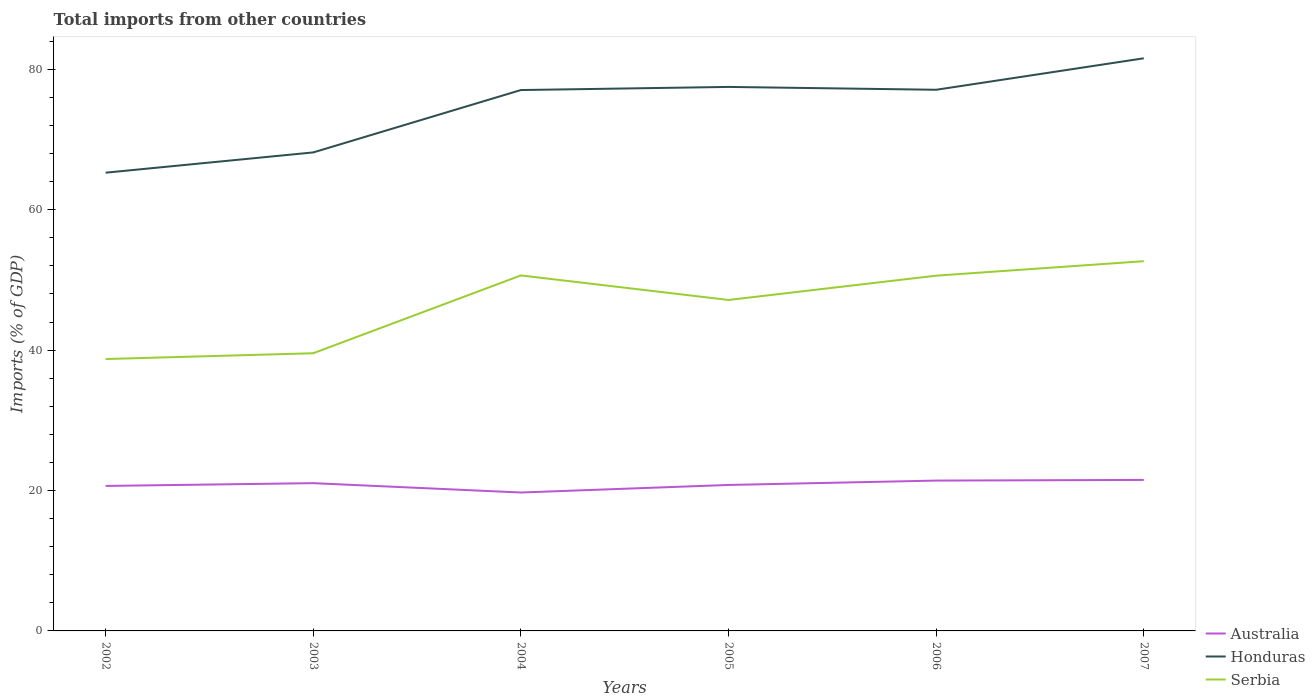How many different coloured lines are there?
Keep it short and to the point. 3. Does the line corresponding to Serbia intersect with the line corresponding to Honduras?
Your answer should be compact. No. Is the number of lines equal to the number of legend labels?
Make the answer very short. Yes. Across all years, what is the maximum total imports in Serbia?
Your response must be concise. 38.73. What is the total total imports in Serbia in the graph?
Provide a short and direct response. 0.03. What is the difference between the highest and the second highest total imports in Serbia?
Provide a short and direct response. 13.94. How many lines are there?
Provide a short and direct response. 3. How many years are there in the graph?
Offer a very short reply. 6. Are the values on the major ticks of Y-axis written in scientific E-notation?
Provide a short and direct response. No. Does the graph contain any zero values?
Keep it short and to the point. No. Does the graph contain grids?
Offer a terse response. No. What is the title of the graph?
Ensure brevity in your answer.  Total imports from other countries. What is the label or title of the X-axis?
Your answer should be very brief. Years. What is the label or title of the Y-axis?
Offer a very short reply. Imports (% of GDP). What is the Imports (% of GDP) of Australia in 2002?
Provide a short and direct response. 20.65. What is the Imports (% of GDP) in Honduras in 2002?
Your answer should be very brief. 65.27. What is the Imports (% of GDP) in Serbia in 2002?
Ensure brevity in your answer.  38.73. What is the Imports (% of GDP) of Australia in 2003?
Provide a short and direct response. 21.05. What is the Imports (% of GDP) of Honduras in 2003?
Provide a short and direct response. 68.15. What is the Imports (% of GDP) in Serbia in 2003?
Provide a short and direct response. 39.55. What is the Imports (% of GDP) of Australia in 2004?
Your response must be concise. 19.71. What is the Imports (% of GDP) of Honduras in 2004?
Make the answer very short. 77.04. What is the Imports (% of GDP) of Serbia in 2004?
Your answer should be very brief. 50.63. What is the Imports (% of GDP) of Australia in 2005?
Give a very brief answer. 20.79. What is the Imports (% of GDP) of Honduras in 2005?
Offer a terse response. 77.48. What is the Imports (% of GDP) of Serbia in 2005?
Give a very brief answer. 47.14. What is the Imports (% of GDP) of Australia in 2006?
Offer a terse response. 21.41. What is the Imports (% of GDP) in Honduras in 2006?
Your answer should be compact. 77.08. What is the Imports (% of GDP) in Serbia in 2006?
Offer a terse response. 50.6. What is the Imports (% of GDP) in Australia in 2007?
Provide a short and direct response. 21.51. What is the Imports (% of GDP) in Honduras in 2007?
Your answer should be very brief. 81.56. What is the Imports (% of GDP) in Serbia in 2007?
Keep it short and to the point. 52.66. Across all years, what is the maximum Imports (% of GDP) in Australia?
Keep it short and to the point. 21.51. Across all years, what is the maximum Imports (% of GDP) of Honduras?
Provide a succinct answer. 81.56. Across all years, what is the maximum Imports (% of GDP) in Serbia?
Your answer should be very brief. 52.66. Across all years, what is the minimum Imports (% of GDP) of Australia?
Your answer should be compact. 19.71. Across all years, what is the minimum Imports (% of GDP) in Honduras?
Make the answer very short. 65.27. Across all years, what is the minimum Imports (% of GDP) of Serbia?
Provide a short and direct response. 38.73. What is the total Imports (% of GDP) of Australia in the graph?
Make the answer very short. 125.12. What is the total Imports (% of GDP) of Honduras in the graph?
Give a very brief answer. 446.58. What is the total Imports (% of GDP) of Serbia in the graph?
Provide a short and direct response. 279.31. What is the difference between the Imports (% of GDP) of Australia in 2002 and that in 2003?
Your answer should be compact. -0.39. What is the difference between the Imports (% of GDP) of Honduras in 2002 and that in 2003?
Your response must be concise. -2.89. What is the difference between the Imports (% of GDP) of Serbia in 2002 and that in 2003?
Offer a very short reply. -0.83. What is the difference between the Imports (% of GDP) of Australia in 2002 and that in 2004?
Keep it short and to the point. 0.94. What is the difference between the Imports (% of GDP) in Honduras in 2002 and that in 2004?
Offer a terse response. -11.77. What is the difference between the Imports (% of GDP) in Serbia in 2002 and that in 2004?
Keep it short and to the point. -11.91. What is the difference between the Imports (% of GDP) of Australia in 2002 and that in 2005?
Your answer should be very brief. -0.14. What is the difference between the Imports (% of GDP) in Honduras in 2002 and that in 2005?
Provide a short and direct response. -12.22. What is the difference between the Imports (% of GDP) of Serbia in 2002 and that in 2005?
Offer a very short reply. -8.41. What is the difference between the Imports (% of GDP) of Australia in 2002 and that in 2006?
Your response must be concise. -0.76. What is the difference between the Imports (% of GDP) of Honduras in 2002 and that in 2006?
Offer a terse response. -11.81. What is the difference between the Imports (% of GDP) in Serbia in 2002 and that in 2006?
Your response must be concise. -11.87. What is the difference between the Imports (% of GDP) in Australia in 2002 and that in 2007?
Offer a very short reply. -0.85. What is the difference between the Imports (% of GDP) of Honduras in 2002 and that in 2007?
Ensure brevity in your answer.  -16.29. What is the difference between the Imports (% of GDP) in Serbia in 2002 and that in 2007?
Offer a very short reply. -13.94. What is the difference between the Imports (% of GDP) in Australia in 2003 and that in 2004?
Your answer should be compact. 1.33. What is the difference between the Imports (% of GDP) in Honduras in 2003 and that in 2004?
Provide a succinct answer. -8.88. What is the difference between the Imports (% of GDP) in Serbia in 2003 and that in 2004?
Offer a terse response. -11.08. What is the difference between the Imports (% of GDP) of Australia in 2003 and that in 2005?
Keep it short and to the point. 0.26. What is the difference between the Imports (% of GDP) in Honduras in 2003 and that in 2005?
Keep it short and to the point. -9.33. What is the difference between the Imports (% of GDP) in Serbia in 2003 and that in 2005?
Ensure brevity in your answer.  -7.59. What is the difference between the Imports (% of GDP) of Australia in 2003 and that in 2006?
Offer a very short reply. -0.37. What is the difference between the Imports (% of GDP) in Honduras in 2003 and that in 2006?
Give a very brief answer. -8.92. What is the difference between the Imports (% of GDP) in Serbia in 2003 and that in 2006?
Your answer should be very brief. -11.05. What is the difference between the Imports (% of GDP) of Australia in 2003 and that in 2007?
Give a very brief answer. -0.46. What is the difference between the Imports (% of GDP) in Honduras in 2003 and that in 2007?
Provide a succinct answer. -13.41. What is the difference between the Imports (% of GDP) in Serbia in 2003 and that in 2007?
Make the answer very short. -13.11. What is the difference between the Imports (% of GDP) of Australia in 2004 and that in 2005?
Offer a very short reply. -1.08. What is the difference between the Imports (% of GDP) of Honduras in 2004 and that in 2005?
Offer a very short reply. -0.45. What is the difference between the Imports (% of GDP) of Serbia in 2004 and that in 2005?
Your response must be concise. 3.49. What is the difference between the Imports (% of GDP) in Australia in 2004 and that in 2006?
Provide a succinct answer. -1.7. What is the difference between the Imports (% of GDP) in Honduras in 2004 and that in 2006?
Keep it short and to the point. -0.04. What is the difference between the Imports (% of GDP) of Serbia in 2004 and that in 2006?
Keep it short and to the point. 0.03. What is the difference between the Imports (% of GDP) of Australia in 2004 and that in 2007?
Provide a short and direct response. -1.79. What is the difference between the Imports (% of GDP) in Honduras in 2004 and that in 2007?
Provide a short and direct response. -4.52. What is the difference between the Imports (% of GDP) of Serbia in 2004 and that in 2007?
Provide a short and direct response. -2.03. What is the difference between the Imports (% of GDP) of Australia in 2005 and that in 2006?
Keep it short and to the point. -0.62. What is the difference between the Imports (% of GDP) in Honduras in 2005 and that in 2006?
Ensure brevity in your answer.  0.41. What is the difference between the Imports (% of GDP) of Serbia in 2005 and that in 2006?
Offer a very short reply. -3.46. What is the difference between the Imports (% of GDP) in Australia in 2005 and that in 2007?
Give a very brief answer. -0.72. What is the difference between the Imports (% of GDP) in Honduras in 2005 and that in 2007?
Your answer should be very brief. -4.08. What is the difference between the Imports (% of GDP) in Serbia in 2005 and that in 2007?
Your answer should be compact. -5.52. What is the difference between the Imports (% of GDP) of Australia in 2006 and that in 2007?
Your answer should be compact. -0.09. What is the difference between the Imports (% of GDP) in Honduras in 2006 and that in 2007?
Provide a short and direct response. -4.48. What is the difference between the Imports (% of GDP) of Serbia in 2006 and that in 2007?
Offer a terse response. -2.06. What is the difference between the Imports (% of GDP) in Australia in 2002 and the Imports (% of GDP) in Honduras in 2003?
Your response must be concise. -47.5. What is the difference between the Imports (% of GDP) of Australia in 2002 and the Imports (% of GDP) of Serbia in 2003?
Provide a succinct answer. -18.9. What is the difference between the Imports (% of GDP) of Honduras in 2002 and the Imports (% of GDP) of Serbia in 2003?
Give a very brief answer. 25.72. What is the difference between the Imports (% of GDP) in Australia in 2002 and the Imports (% of GDP) in Honduras in 2004?
Offer a very short reply. -56.39. What is the difference between the Imports (% of GDP) in Australia in 2002 and the Imports (% of GDP) in Serbia in 2004?
Your answer should be very brief. -29.98. What is the difference between the Imports (% of GDP) in Honduras in 2002 and the Imports (% of GDP) in Serbia in 2004?
Keep it short and to the point. 14.63. What is the difference between the Imports (% of GDP) of Australia in 2002 and the Imports (% of GDP) of Honduras in 2005?
Offer a terse response. -56.83. What is the difference between the Imports (% of GDP) of Australia in 2002 and the Imports (% of GDP) of Serbia in 2005?
Offer a very short reply. -26.49. What is the difference between the Imports (% of GDP) in Honduras in 2002 and the Imports (% of GDP) in Serbia in 2005?
Your response must be concise. 18.13. What is the difference between the Imports (% of GDP) in Australia in 2002 and the Imports (% of GDP) in Honduras in 2006?
Your answer should be compact. -56.43. What is the difference between the Imports (% of GDP) in Australia in 2002 and the Imports (% of GDP) in Serbia in 2006?
Give a very brief answer. -29.95. What is the difference between the Imports (% of GDP) in Honduras in 2002 and the Imports (% of GDP) in Serbia in 2006?
Make the answer very short. 14.67. What is the difference between the Imports (% of GDP) in Australia in 2002 and the Imports (% of GDP) in Honduras in 2007?
Your answer should be very brief. -60.91. What is the difference between the Imports (% of GDP) of Australia in 2002 and the Imports (% of GDP) of Serbia in 2007?
Ensure brevity in your answer.  -32.01. What is the difference between the Imports (% of GDP) of Honduras in 2002 and the Imports (% of GDP) of Serbia in 2007?
Your answer should be very brief. 12.6. What is the difference between the Imports (% of GDP) in Australia in 2003 and the Imports (% of GDP) in Honduras in 2004?
Give a very brief answer. -55.99. What is the difference between the Imports (% of GDP) in Australia in 2003 and the Imports (% of GDP) in Serbia in 2004?
Provide a succinct answer. -29.59. What is the difference between the Imports (% of GDP) of Honduras in 2003 and the Imports (% of GDP) of Serbia in 2004?
Give a very brief answer. 17.52. What is the difference between the Imports (% of GDP) of Australia in 2003 and the Imports (% of GDP) of Honduras in 2005?
Ensure brevity in your answer.  -56.44. What is the difference between the Imports (% of GDP) in Australia in 2003 and the Imports (% of GDP) in Serbia in 2005?
Ensure brevity in your answer.  -26.09. What is the difference between the Imports (% of GDP) in Honduras in 2003 and the Imports (% of GDP) in Serbia in 2005?
Make the answer very short. 21.02. What is the difference between the Imports (% of GDP) in Australia in 2003 and the Imports (% of GDP) in Honduras in 2006?
Give a very brief answer. -56.03. What is the difference between the Imports (% of GDP) in Australia in 2003 and the Imports (% of GDP) in Serbia in 2006?
Give a very brief answer. -29.55. What is the difference between the Imports (% of GDP) in Honduras in 2003 and the Imports (% of GDP) in Serbia in 2006?
Your response must be concise. 17.55. What is the difference between the Imports (% of GDP) of Australia in 2003 and the Imports (% of GDP) of Honduras in 2007?
Ensure brevity in your answer.  -60.52. What is the difference between the Imports (% of GDP) in Australia in 2003 and the Imports (% of GDP) in Serbia in 2007?
Provide a succinct answer. -31.62. What is the difference between the Imports (% of GDP) in Honduras in 2003 and the Imports (% of GDP) in Serbia in 2007?
Your answer should be compact. 15.49. What is the difference between the Imports (% of GDP) of Australia in 2004 and the Imports (% of GDP) of Honduras in 2005?
Provide a succinct answer. -57.77. What is the difference between the Imports (% of GDP) in Australia in 2004 and the Imports (% of GDP) in Serbia in 2005?
Make the answer very short. -27.42. What is the difference between the Imports (% of GDP) of Honduras in 2004 and the Imports (% of GDP) of Serbia in 2005?
Your answer should be compact. 29.9. What is the difference between the Imports (% of GDP) in Australia in 2004 and the Imports (% of GDP) in Honduras in 2006?
Your answer should be very brief. -57.36. What is the difference between the Imports (% of GDP) in Australia in 2004 and the Imports (% of GDP) in Serbia in 2006?
Provide a short and direct response. -30.88. What is the difference between the Imports (% of GDP) in Honduras in 2004 and the Imports (% of GDP) in Serbia in 2006?
Give a very brief answer. 26.44. What is the difference between the Imports (% of GDP) of Australia in 2004 and the Imports (% of GDP) of Honduras in 2007?
Provide a short and direct response. -61.85. What is the difference between the Imports (% of GDP) in Australia in 2004 and the Imports (% of GDP) in Serbia in 2007?
Ensure brevity in your answer.  -32.95. What is the difference between the Imports (% of GDP) in Honduras in 2004 and the Imports (% of GDP) in Serbia in 2007?
Your answer should be compact. 24.38. What is the difference between the Imports (% of GDP) in Australia in 2005 and the Imports (% of GDP) in Honduras in 2006?
Give a very brief answer. -56.29. What is the difference between the Imports (% of GDP) in Australia in 2005 and the Imports (% of GDP) in Serbia in 2006?
Keep it short and to the point. -29.81. What is the difference between the Imports (% of GDP) of Honduras in 2005 and the Imports (% of GDP) of Serbia in 2006?
Provide a short and direct response. 26.88. What is the difference between the Imports (% of GDP) in Australia in 2005 and the Imports (% of GDP) in Honduras in 2007?
Provide a short and direct response. -60.77. What is the difference between the Imports (% of GDP) of Australia in 2005 and the Imports (% of GDP) of Serbia in 2007?
Your answer should be compact. -31.87. What is the difference between the Imports (% of GDP) of Honduras in 2005 and the Imports (% of GDP) of Serbia in 2007?
Your answer should be compact. 24.82. What is the difference between the Imports (% of GDP) of Australia in 2006 and the Imports (% of GDP) of Honduras in 2007?
Your answer should be very brief. -60.15. What is the difference between the Imports (% of GDP) of Australia in 2006 and the Imports (% of GDP) of Serbia in 2007?
Keep it short and to the point. -31.25. What is the difference between the Imports (% of GDP) of Honduras in 2006 and the Imports (% of GDP) of Serbia in 2007?
Provide a short and direct response. 24.41. What is the average Imports (% of GDP) of Australia per year?
Offer a terse response. 20.85. What is the average Imports (% of GDP) in Honduras per year?
Your answer should be compact. 74.43. What is the average Imports (% of GDP) in Serbia per year?
Give a very brief answer. 46.55. In the year 2002, what is the difference between the Imports (% of GDP) of Australia and Imports (% of GDP) of Honduras?
Provide a short and direct response. -44.62. In the year 2002, what is the difference between the Imports (% of GDP) in Australia and Imports (% of GDP) in Serbia?
Your answer should be compact. -18.07. In the year 2002, what is the difference between the Imports (% of GDP) of Honduras and Imports (% of GDP) of Serbia?
Make the answer very short. 26.54. In the year 2003, what is the difference between the Imports (% of GDP) in Australia and Imports (% of GDP) in Honduras?
Your answer should be very brief. -47.11. In the year 2003, what is the difference between the Imports (% of GDP) in Australia and Imports (% of GDP) in Serbia?
Offer a very short reply. -18.5. In the year 2003, what is the difference between the Imports (% of GDP) in Honduras and Imports (% of GDP) in Serbia?
Keep it short and to the point. 28.6. In the year 2004, what is the difference between the Imports (% of GDP) in Australia and Imports (% of GDP) in Honduras?
Make the answer very short. -57.32. In the year 2004, what is the difference between the Imports (% of GDP) in Australia and Imports (% of GDP) in Serbia?
Keep it short and to the point. -30.92. In the year 2004, what is the difference between the Imports (% of GDP) of Honduras and Imports (% of GDP) of Serbia?
Your response must be concise. 26.41. In the year 2005, what is the difference between the Imports (% of GDP) in Australia and Imports (% of GDP) in Honduras?
Offer a terse response. -56.69. In the year 2005, what is the difference between the Imports (% of GDP) in Australia and Imports (% of GDP) in Serbia?
Give a very brief answer. -26.35. In the year 2005, what is the difference between the Imports (% of GDP) of Honduras and Imports (% of GDP) of Serbia?
Ensure brevity in your answer.  30.34. In the year 2006, what is the difference between the Imports (% of GDP) in Australia and Imports (% of GDP) in Honduras?
Offer a terse response. -55.66. In the year 2006, what is the difference between the Imports (% of GDP) in Australia and Imports (% of GDP) in Serbia?
Give a very brief answer. -29.19. In the year 2006, what is the difference between the Imports (% of GDP) of Honduras and Imports (% of GDP) of Serbia?
Make the answer very short. 26.48. In the year 2007, what is the difference between the Imports (% of GDP) in Australia and Imports (% of GDP) in Honduras?
Provide a short and direct response. -60.06. In the year 2007, what is the difference between the Imports (% of GDP) in Australia and Imports (% of GDP) in Serbia?
Make the answer very short. -31.16. In the year 2007, what is the difference between the Imports (% of GDP) in Honduras and Imports (% of GDP) in Serbia?
Provide a short and direct response. 28.9. What is the ratio of the Imports (% of GDP) of Australia in 2002 to that in 2003?
Make the answer very short. 0.98. What is the ratio of the Imports (% of GDP) in Honduras in 2002 to that in 2003?
Ensure brevity in your answer.  0.96. What is the ratio of the Imports (% of GDP) in Serbia in 2002 to that in 2003?
Your answer should be compact. 0.98. What is the ratio of the Imports (% of GDP) in Australia in 2002 to that in 2004?
Ensure brevity in your answer.  1.05. What is the ratio of the Imports (% of GDP) of Honduras in 2002 to that in 2004?
Your answer should be compact. 0.85. What is the ratio of the Imports (% of GDP) in Serbia in 2002 to that in 2004?
Make the answer very short. 0.76. What is the ratio of the Imports (% of GDP) in Honduras in 2002 to that in 2005?
Offer a very short reply. 0.84. What is the ratio of the Imports (% of GDP) in Serbia in 2002 to that in 2005?
Provide a succinct answer. 0.82. What is the ratio of the Imports (% of GDP) of Australia in 2002 to that in 2006?
Your answer should be very brief. 0.96. What is the ratio of the Imports (% of GDP) in Honduras in 2002 to that in 2006?
Provide a short and direct response. 0.85. What is the ratio of the Imports (% of GDP) in Serbia in 2002 to that in 2006?
Offer a terse response. 0.77. What is the ratio of the Imports (% of GDP) of Australia in 2002 to that in 2007?
Your answer should be very brief. 0.96. What is the ratio of the Imports (% of GDP) of Honduras in 2002 to that in 2007?
Ensure brevity in your answer.  0.8. What is the ratio of the Imports (% of GDP) in Serbia in 2002 to that in 2007?
Your answer should be compact. 0.74. What is the ratio of the Imports (% of GDP) in Australia in 2003 to that in 2004?
Ensure brevity in your answer.  1.07. What is the ratio of the Imports (% of GDP) in Honduras in 2003 to that in 2004?
Provide a succinct answer. 0.88. What is the ratio of the Imports (% of GDP) of Serbia in 2003 to that in 2004?
Keep it short and to the point. 0.78. What is the ratio of the Imports (% of GDP) in Australia in 2003 to that in 2005?
Offer a terse response. 1.01. What is the ratio of the Imports (% of GDP) in Honduras in 2003 to that in 2005?
Provide a short and direct response. 0.88. What is the ratio of the Imports (% of GDP) of Serbia in 2003 to that in 2005?
Make the answer very short. 0.84. What is the ratio of the Imports (% of GDP) of Australia in 2003 to that in 2006?
Your response must be concise. 0.98. What is the ratio of the Imports (% of GDP) of Honduras in 2003 to that in 2006?
Your answer should be very brief. 0.88. What is the ratio of the Imports (% of GDP) of Serbia in 2003 to that in 2006?
Give a very brief answer. 0.78. What is the ratio of the Imports (% of GDP) of Australia in 2003 to that in 2007?
Provide a short and direct response. 0.98. What is the ratio of the Imports (% of GDP) in Honduras in 2003 to that in 2007?
Offer a very short reply. 0.84. What is the ratio of the Imports (% of GDP) of Serbia in 2003 to that in 2007?
Make the answer very short. 0.75. What is the ratio of the Imports (% of GDP) of Australia in 2004 to that in 2005?
Provide a succinct answer. 0.95. What is the ratio of the Imports (% of GDP) in Honduras in 2004 to that in 2005?
Your answer should be very brief. 0.99. What is the ratio of the Imports (% of GDP) of Serbia in 2004 to that in 2005?
Provide a short and direct response. 1.07. What is the ratio of the Imports (% of GDP) in Australia in 2004 to that in 2006?
Give a very brief answer. 0.92. What is the ratio of the Imports (% of GDP) in Serbia in 2004 to that in 2006?
Provide a short and direct response. 1. What is the ratio of the Imports (% of GDP) of Australia in 2004 to that in 2007?
Your answer should be compact. 0.92. What is the ratio of the Imports (% of GDP) in Honduras in 2004 to that in 2007?
Make the answer very short. 0.94. What is the ratio of the Imports (% of GDP) in Serbia in 2004 to that in 2007?
Offer a very short reply. 0.96. What is the ratio of the Imports (% of GDP) of Australia in 2005 to that in 2006?
Offer a terse response. 0.97. What is the ratio of the Imports (% of GDP) in Honduras in 2005 to that in 2006?
Ensure brevity in your answer.  1.01. What is the ratio of the Imports (% of GDP) in Serbia in 2005 to that in 2006?
Provide a short and direct response. 0.93. What is the ratio of the Imports (% of GDP) in Australia in 2005 to that in 2007?
Provide a short and direct response. 0.97. What is the ratio of the Imports (% of GDP) of Serbia in 2005 to that in 2007?
Offer a very short reply. 0.9. What is the ratio of the Imports (% of GDP) of Australia in 2006 to that in 2007?
Your answer should be compact. 1. What is the ratio of the Imports (% of GDP) of Honduras in 2006 to that in 2007?
Your answer should be very brief. 0.94. What is the ratio of the Imports (% of GDP) in Serbia in 2006 to that in 2007?
Give a very brief answer. 0.96. What is the difference between the highest and the second highest Imports (% of GDP) in Australia?
Offer a very short reply. 0.09. What is the difference between the highest and the second highest Imports (% of GDP) of Honduras?
Make the answer very short. 4.08. What is the difference between the highest and the second highest Imports (% of GDP) of Serbia?
Your answer should be compact. 2.03. What is the difference between the highest and the lowest Imports (% of GDP) in Australia?
Give a very brief answer. 1.79. What is the difference between the highest and the lowest Imports (% of GDP) in Honduras?
Provide a short and direct response. 16.29. What is the difference between the highest and the lowest Imports (% of GDP) in Serbia?
Offer a terse response. 13.94. 